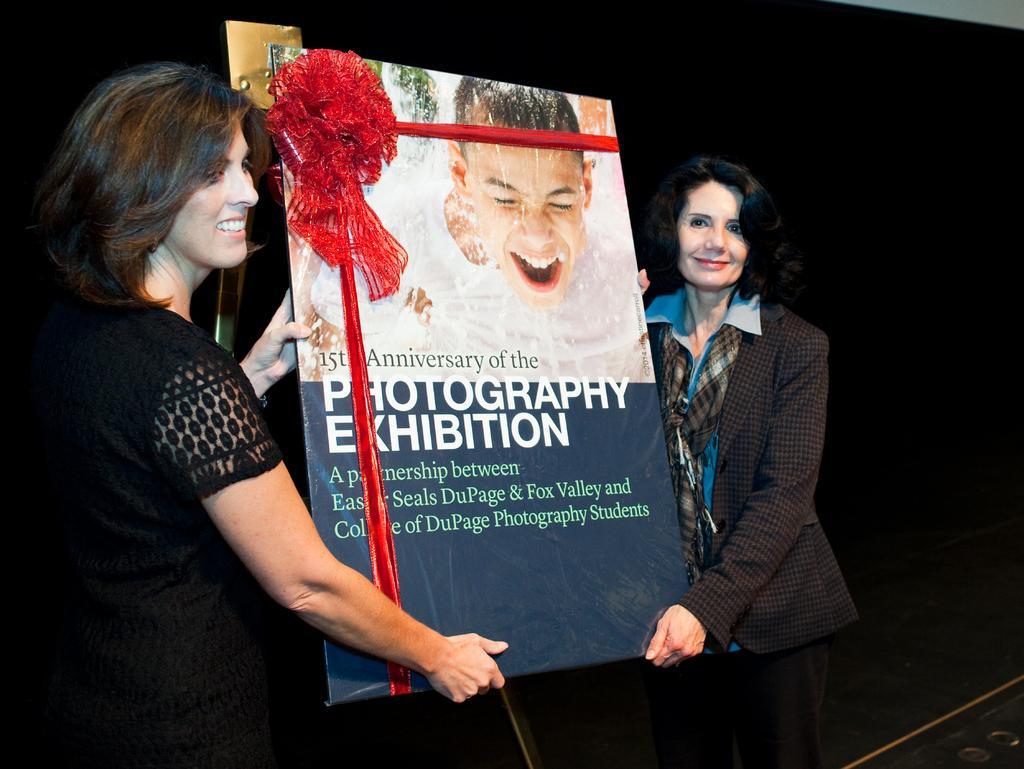Can you describe this image briefly? In this image in the center there are two woman who are standing and they are holding some board, on that board there is some text and a ribbon. 